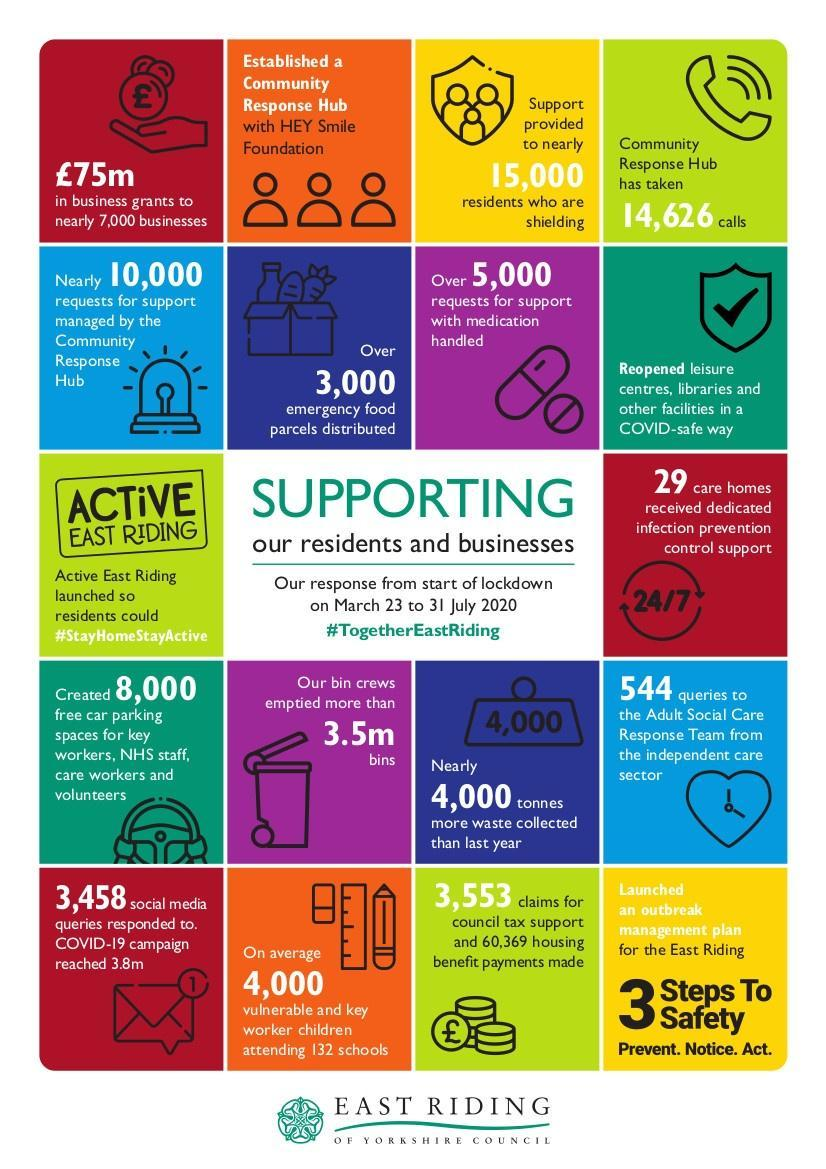How many requests for medication support were handled by the East Riding of Yorkshire Council from March 23 to 31 July 2020?
Answer the question with a short phrase. Over 5,000 How much is the value of business grants (in pounds) provided by the  East Riding of Yorkshire Council from March 23 to 31 July 2020? 75m How many calls were taken by the community response hub as per the survey? 14,626 